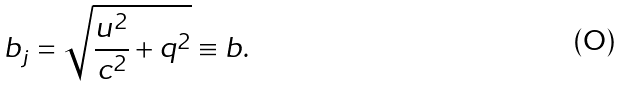<formula> <loc_0><loc_0><loc_500><loc_500>b _ { j } = \sqrt { \frac { u ^ { 2 } } { c ^ { 2 } } + q ^ { 2 } } \equiv b .</formula> 